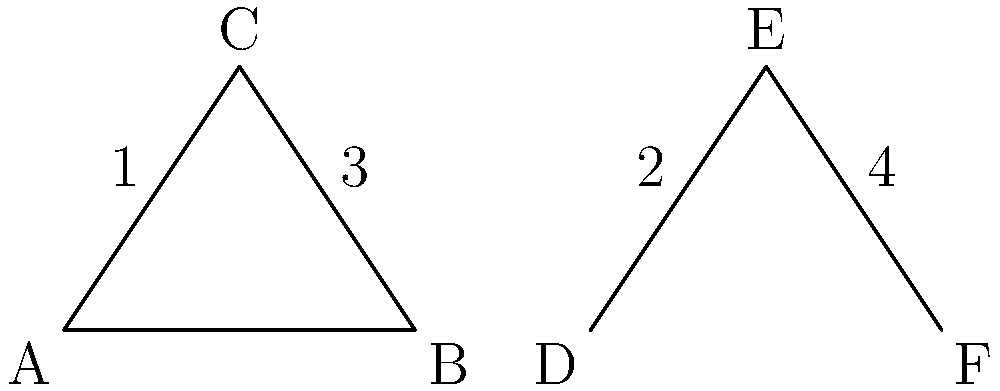In planning a budget-friendly wedding, you're comparing two types of bouquet arrangements: a triangular and a fan-shaped design. The triangular bouquet is represented by triangle ABC, while the fan-shaped bouquet is represented by triangle DEF. Which two line segments in the diagram are congruent, potentially allowing for cost-effective use of similar materials? To identify congruent parts in these bouquet arrangements, we need to analyze the given information and use our knowledge of congruence in triangles. Let's approach this step-by-step:

1. In triangle ABC:
   - AC is a side of the triangle
   - Line segment 1 is the altitude from C to AB

2. In triangle DEF:
   - DE is a side of the triangle
   - Line segment 2 is the altitude from E to DF

3. To determine if AC and DE are congruent, we would need more information about their lengths.

4. However, we can compare the altitudes (line segments 1 and 2):
   - Both are perpendicular to the base of their respective triangles
   - Both extend from the vertex to the opposite side

5. In congruent triangles, corresponding altitudes are congruent.

6. While we don't have enough information to determine if the entire triangles are congruent, we can see that the altitudes (line segments 1 and 2) have the same geometric relationship within their respective triangles.

7. Therefore, line segments 1 and 2 are likely to be congruent, representing similar structural elements in both bouquet designs.

This congruence could allow for the use of similar materials or techniques in both arrangements, potentially reducing costs.
Answer: Line segments 1 and 2 